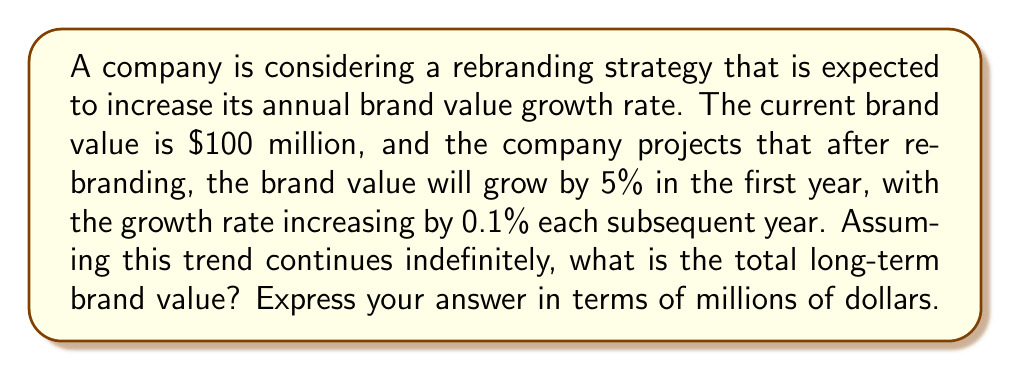Help me with this question. Let's approach this step-by-step:

1) First, let's define our series. The brand value after each year can be represented as:

   Year 0: $100 million (initial value)
   Year 1: $100 * (1 + 0.05) = $100 * 1.05
   Year 2: $100 * 1.05 * (1 + 0.051) = $100 * 1.05 * 1.051
   Year 3: $100 * 1.05 * 1.051 * (1 + 0.052) = $100 * 1.05 * 1.051 * 1.052

2) We can see a pattern forming. The general term for the nth year (starting from n=0) is:

   $$a_n = 100 \prod_{k=1}^n (1 + 0.05 + 0.001k)$$

3) The total long-term brand value is the sum of this infinite series:

   $$S_{\infty} = \sum_{n=0}^{\infty} a_n$$

4) This series doesn't have a simple closed form, but we can use the ratio test to determine if it converges:

   $$\lim_{n \to \infty} \left|\frac{a_{n+1}}{a_n}\right| = \lim_{n \to \infty} (1 + 0.05 + 0.001(n+1))$$

5) This limit is clearly greater than 1, which means the series diverges.

6) In financial terms, this divergence implies that if this growth trend continues indefinitely, the brand value would grow without bound, approaching infinity.

7) However, in reality, infinite growth is not possible due to market saturation, competition, and other factors. The model would need to be adjusted for more realistic long-term projections.

8) For the purposes of this calculus problem, we can say that the long-term brand value approaches infinity, written mathematically as:

   $$\lim_{n \to \infty} S_n = \infty$$
Answer: $\infty$ million 